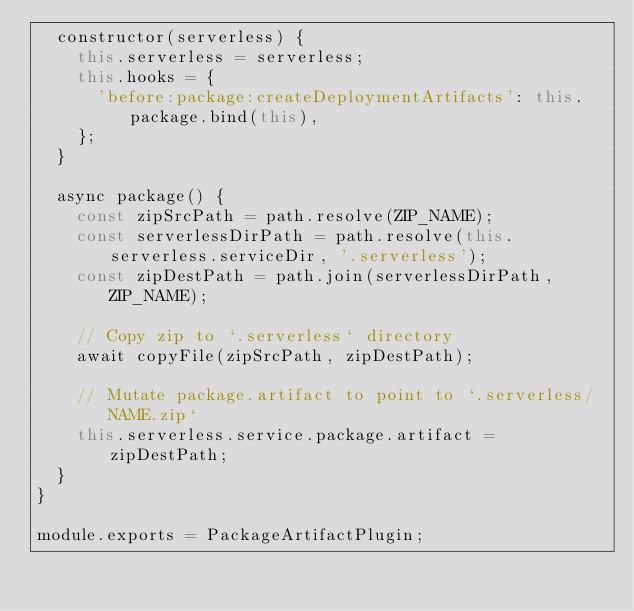Convert code to text. <code><loc_0><loc_0><loc_500><loc_500><_JavaScript_>  constructor(serverless) {
    this.serverless = serverless;
    this.hooks = {
      'before:package:createDeploymentArtifacts': this.package.bind(this),
    };
  }

  async package() {
    const zipSrcPath = path.resolve(ZIP_NAME);
    const serverlessDirPath = path.resolve(this.serverless.serviceDir, '.serverless');
    const zipDestPath = path.join(serverlessDirPath, ZIP_NAME);

    // Copy zip to `.serverless` directory
    await copyFile(zipSrcPath, zipDestPath);

    // Mutate package.artifact to point to `.serverless/NAME.zip`
    this.serverless.service.package.artifact = zipDestPath;
  }
}

module.exports = PackageArtifactPlugin;
</code> 